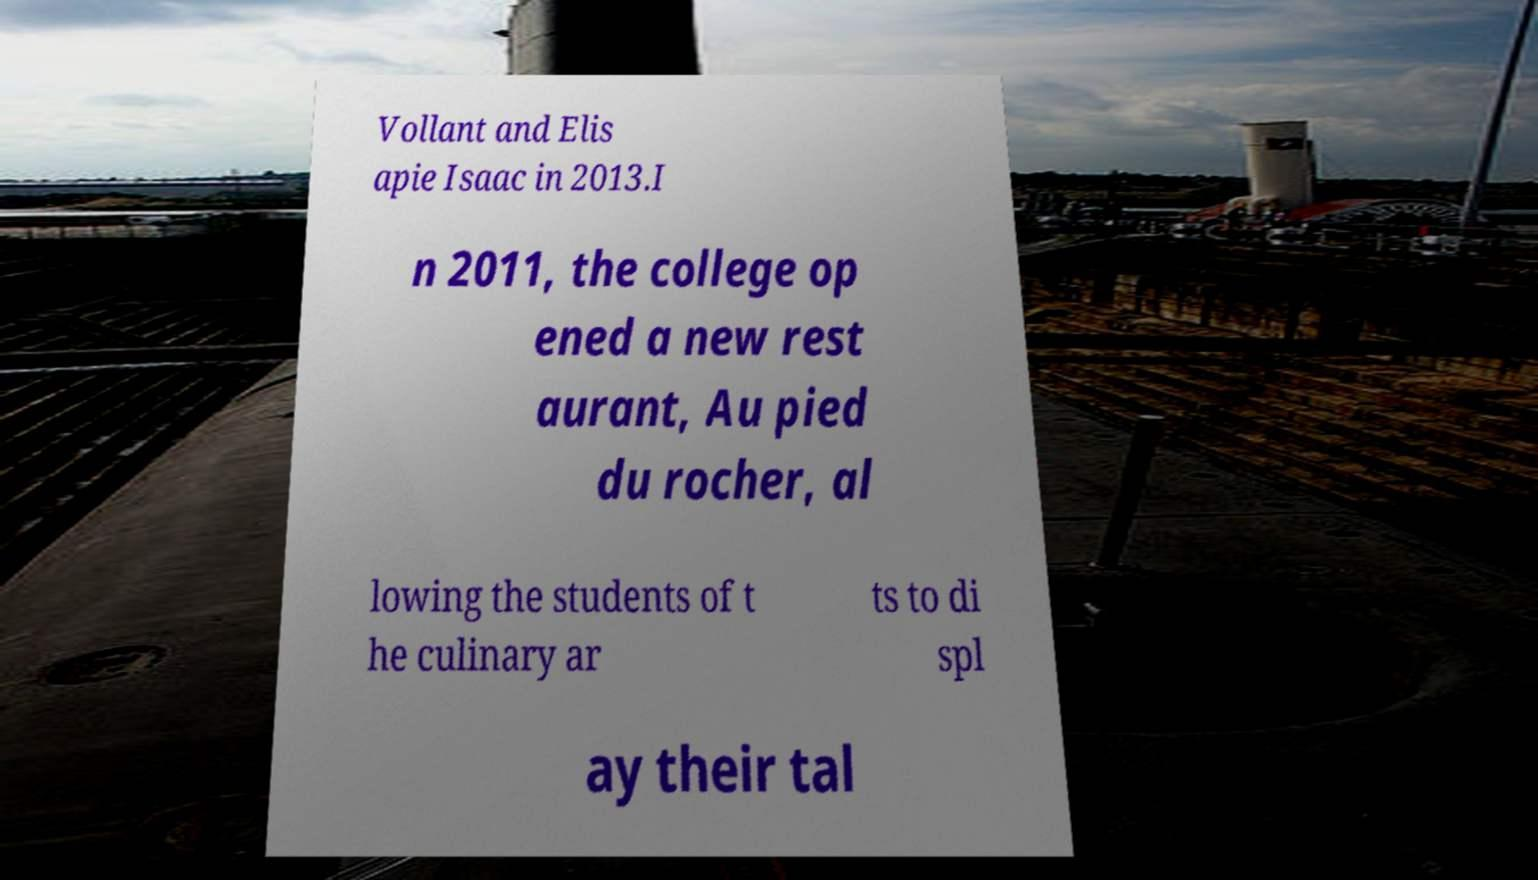For documentation purposes, I need the text within this image transcribed. Could you provide that? Vollant and Elis apie Isaac in 2013.I n 2011, the college op ened a new rest aurant, Au pied du rocher, al lowing the students of t he culinary ar ts to di spl ay their tal 